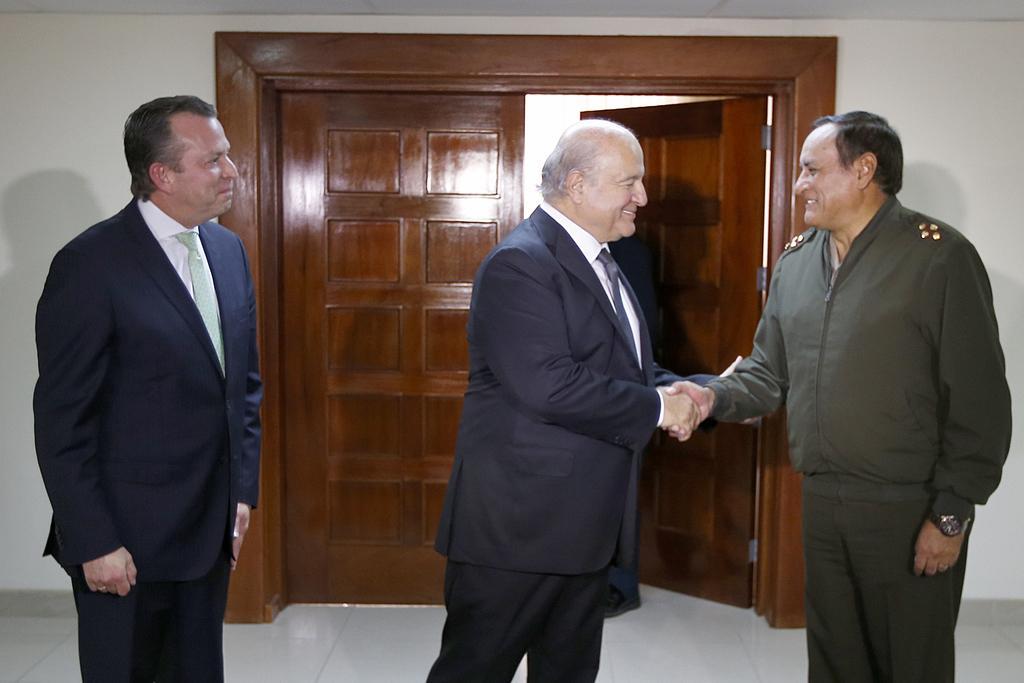Can you describe this image briefly? In this image there are two persons shaking hands with each other are having a smile on their face, beside them there is another person standing, behind them there is a wooden door opened. 